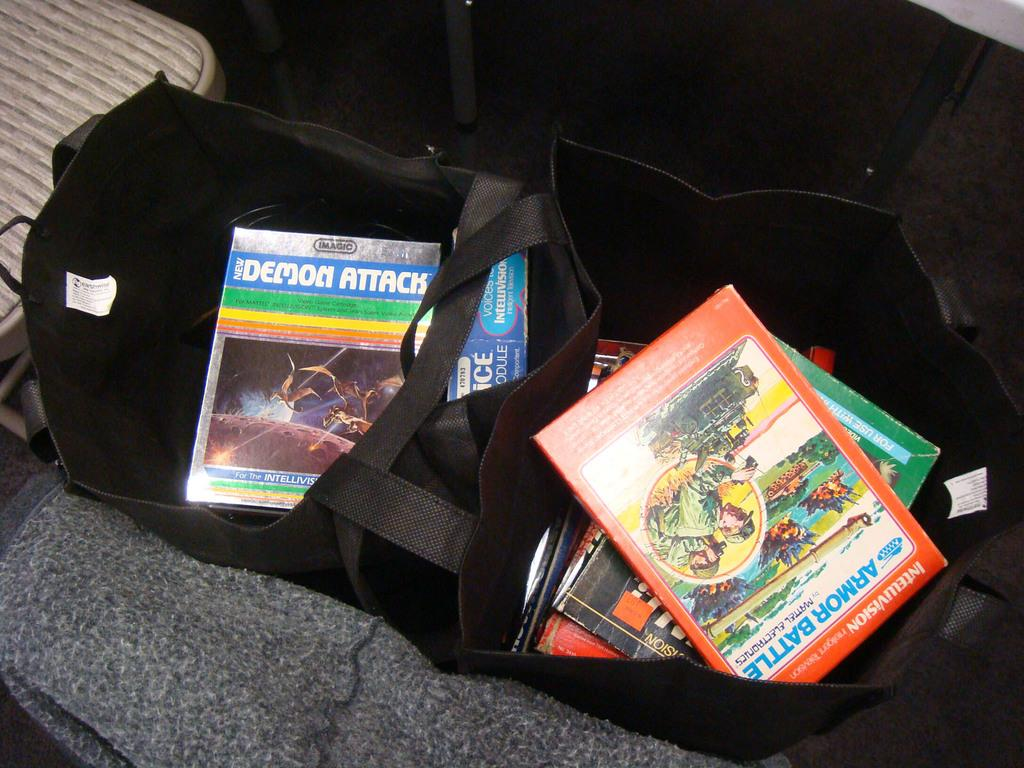<image>
Render a clear and concise summary of the photo. Some books in a black holder, one of which has the word Attack on the cover. 